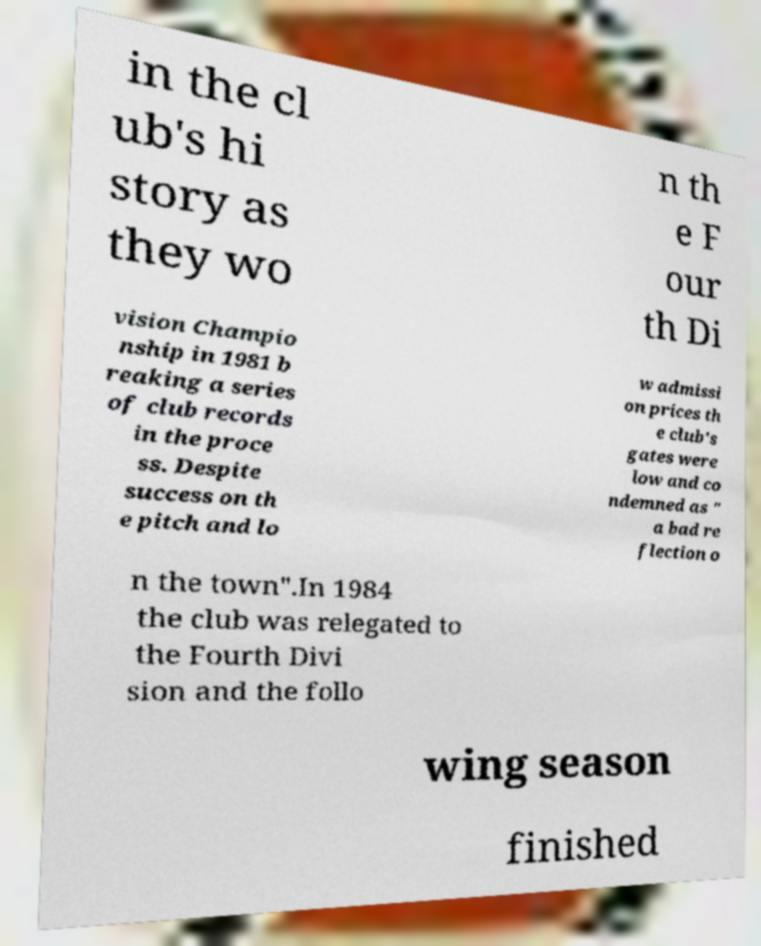What messages or text are displayed in this image? I need them in a readable, typed format. in the cl ub's hi story as they wo n th e F our th Di vision Champio nship in 1981 b reaking a series of club records in the proce ss. Despite success on th e pitch and lo w admissi on prices th e club's gates were low and co ndemned as " a bad re flection o n the town".In 1984 the club was relegated to the Fourth Divi sion and the follo wing season finished 